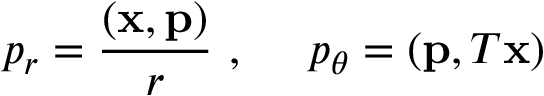Convert formula to latex. <formula><loc_0><loc_0><loc_500><loc_500>p _ { r } = \frac { ( { x } , { p } ) } { r } \ , \quad p _ { \theta } = ( { p } , T { x } )</formula> 